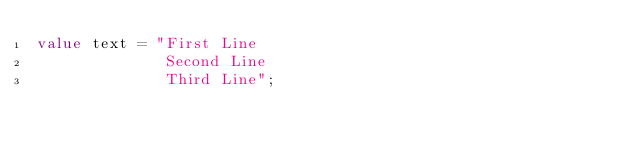<code> <loc_0><loc_0><loc_500><loc_500><_Ceylon_>value text = "First Line
              Second Line
              Third Line";
</code> 